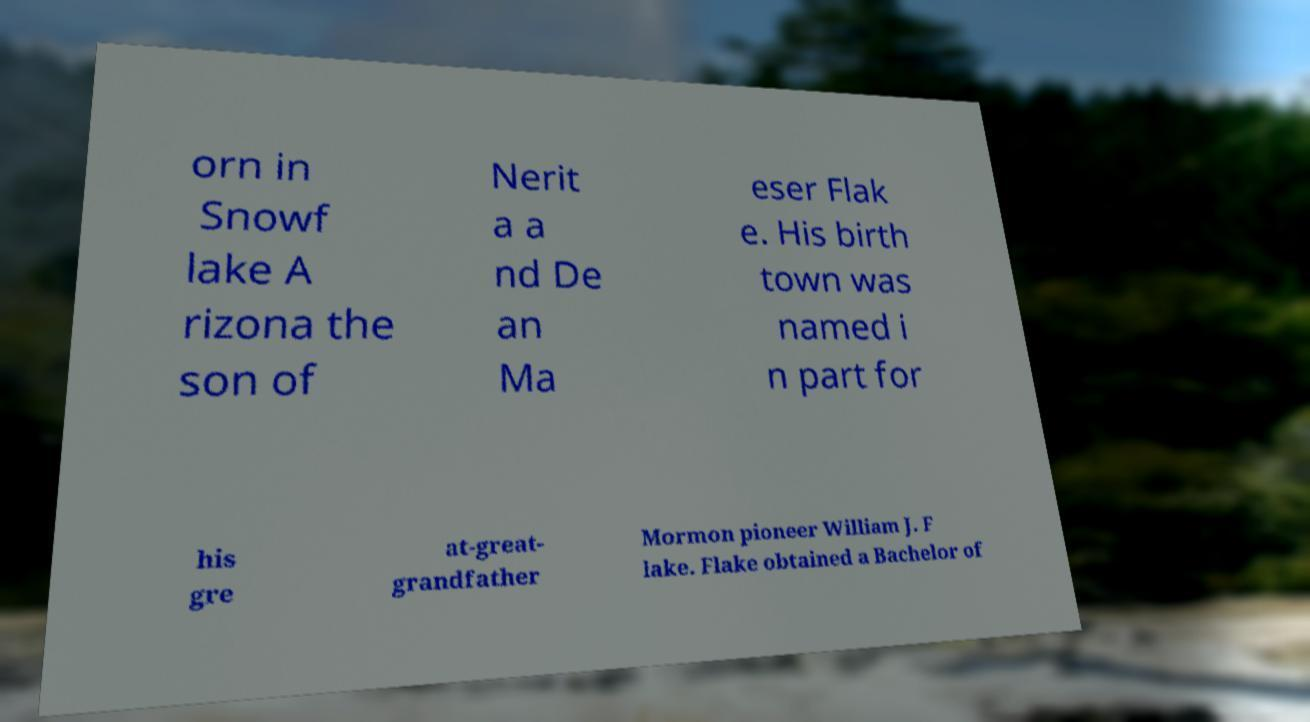Please identify and transcribe the text found in this image. orn in Snowf lake A rizona the son of Nerit a a nd De an Ma eser Flak e. His birth town was named i n part for his gre at-great- grandfather Mormon pioneer William J. F lake. Flake obtained a Bachelor of 